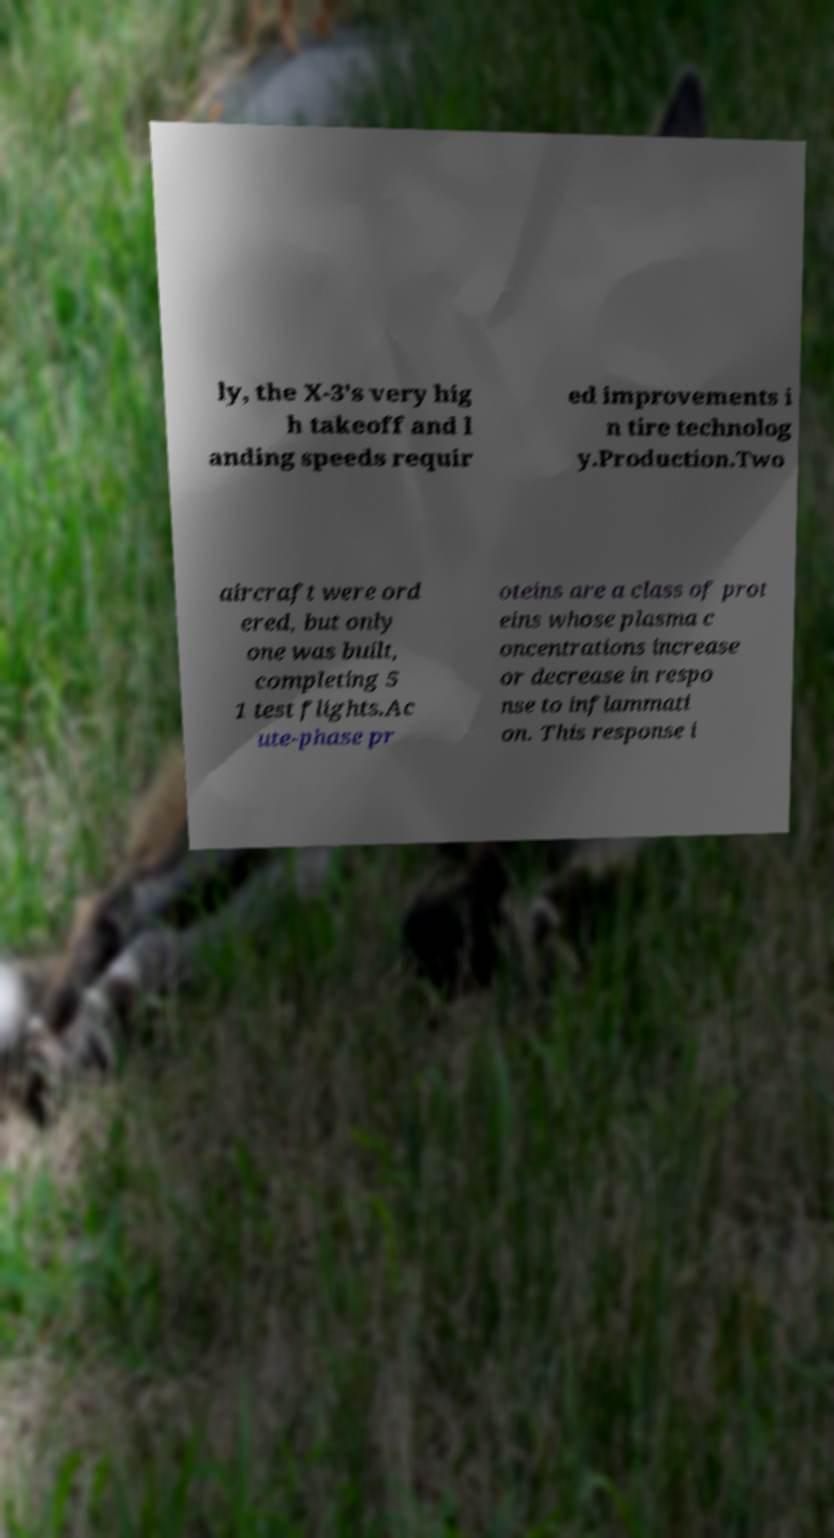Could you extract and type out the text from this image? ly, the X-3's very hig h takeoff and l anding speeds requir ed improvements i n tire technolog y.Production.Two aircraft were ord ered, but only one was built, completing 5 1 test flights.Ac ute-phase pr oteins are a class of prot eins whose plasma c oncentrations increase or decrease in respo nse to inflammati on. This response i 